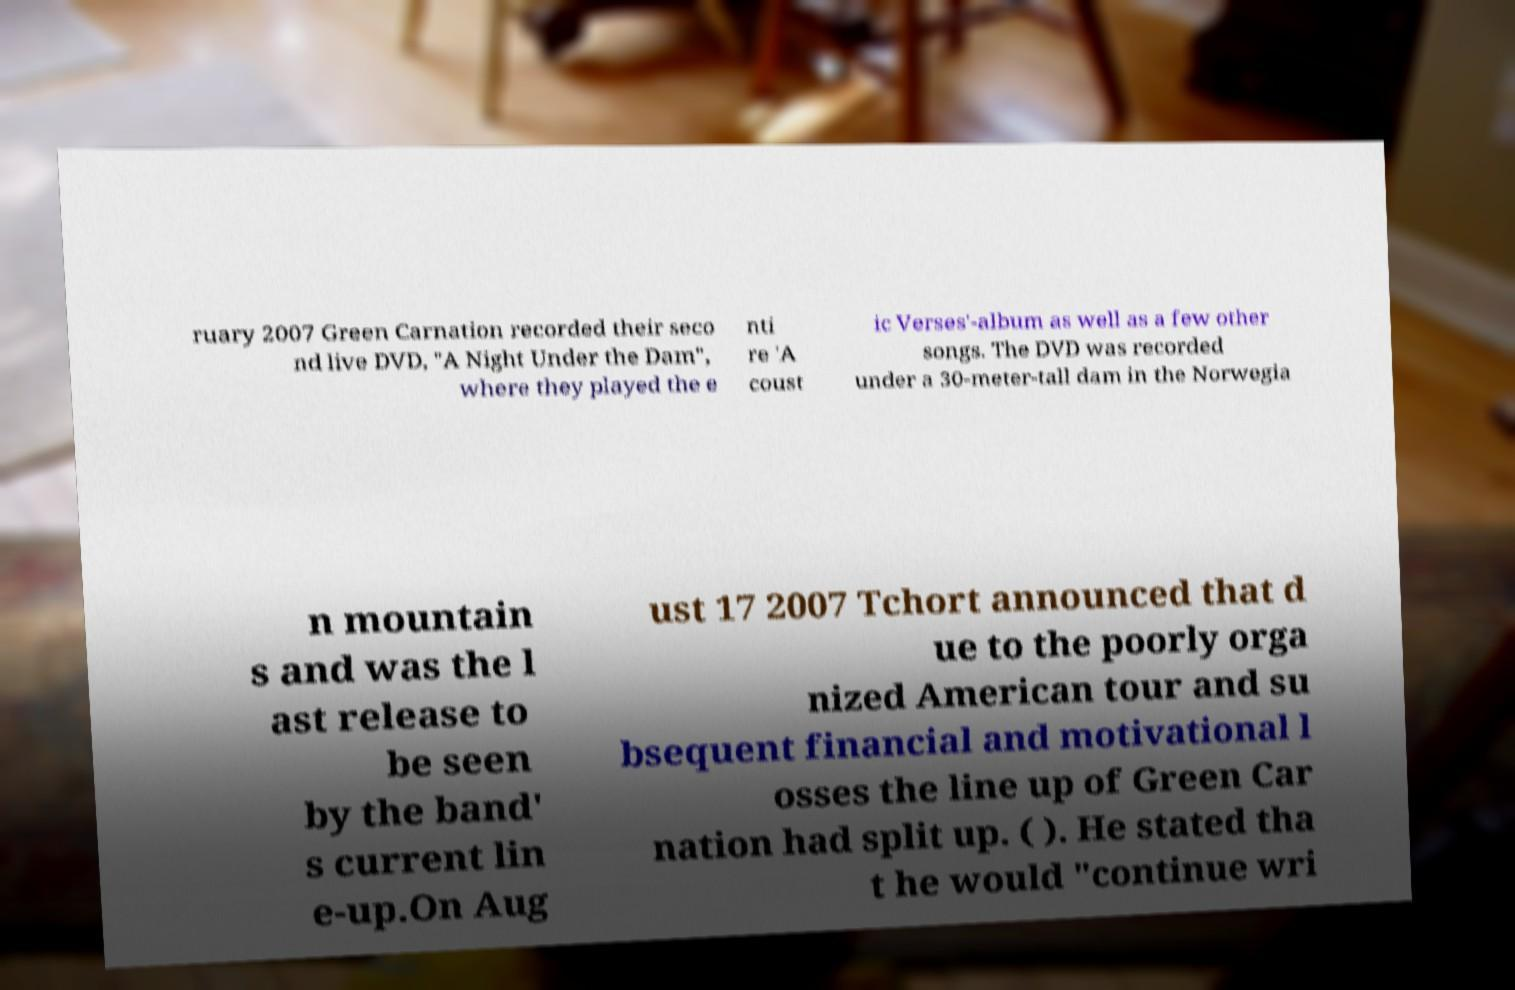Can you accurately transcribe the text from the provided image for me? ruary 2007 Green Carnation recorded their seco nd live DVD, "A Night Under the Dam", where they played the e nti re 'A coust ic Verses'-album as well as a few other songs. The DVD was recorded under a 30-meter-tall dam in the Norwegia n mountain s and was the l ast release to be seen by the band' s current lin e-up.On Aug ust 17 2007 Tchort announced that d ue to the poorly orga nized American tour and su bsequent financial and motivational l osses the line up of Green Car nation had split up. ( ). He stated tha t he would "continue wri 